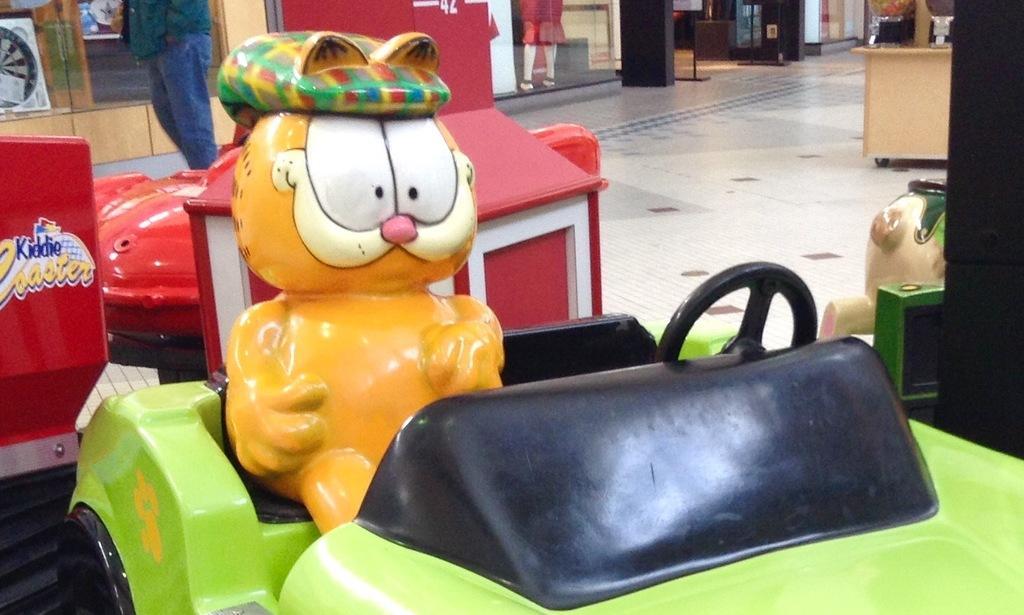Please provide a concise description of this image. It is a toy sitting on the toy car, this car is in green color, behind this there is a red color car in this image. 